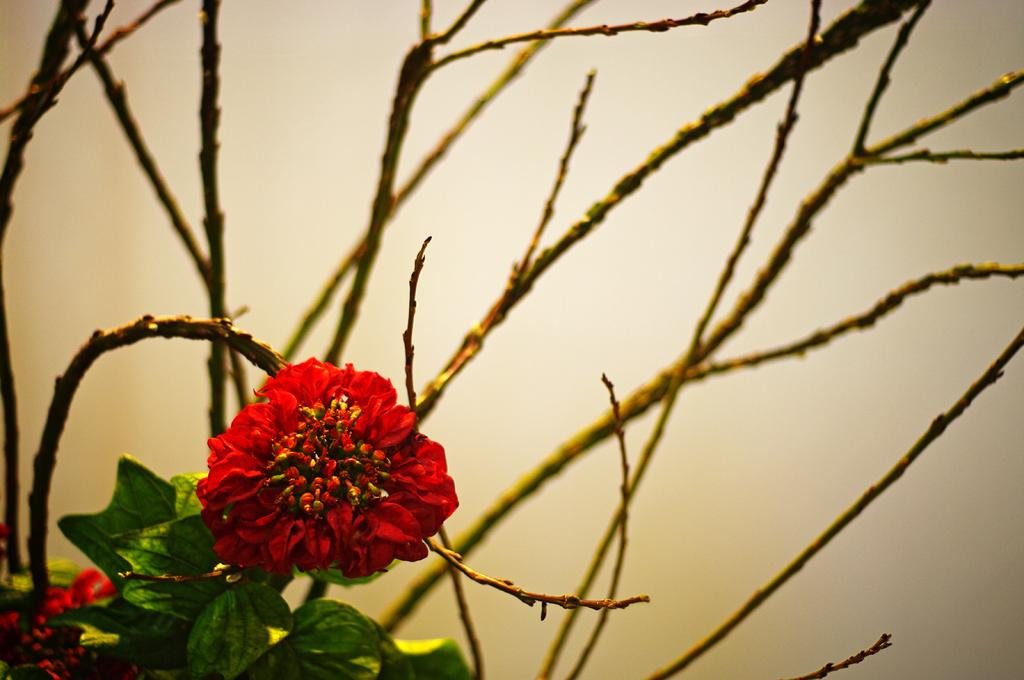What type of flower can be seen in the image? There is a red color flower on a plant in the image. What else can be seen on the plant besides the flower? There are stems visible in the image. Can you describe the background of the image? The background of the image is blurry. What type of earthquake can be seen in the image? There is no earthquake present in the image; it features a red color flower on a plant with blurry background. 